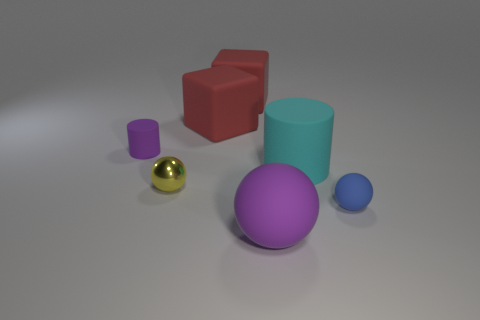What material do the objects look like they are made of in general, and do they appear solid or hollow? The objects in the image seem to be made of various materials. The shiny objects, such as the small ball, likely represent metals or polished ceramics, while the others could represent plastics or painted wood. They all appear to be solid, given the absence of any visible openings or seams that would suggest they are hollow. 